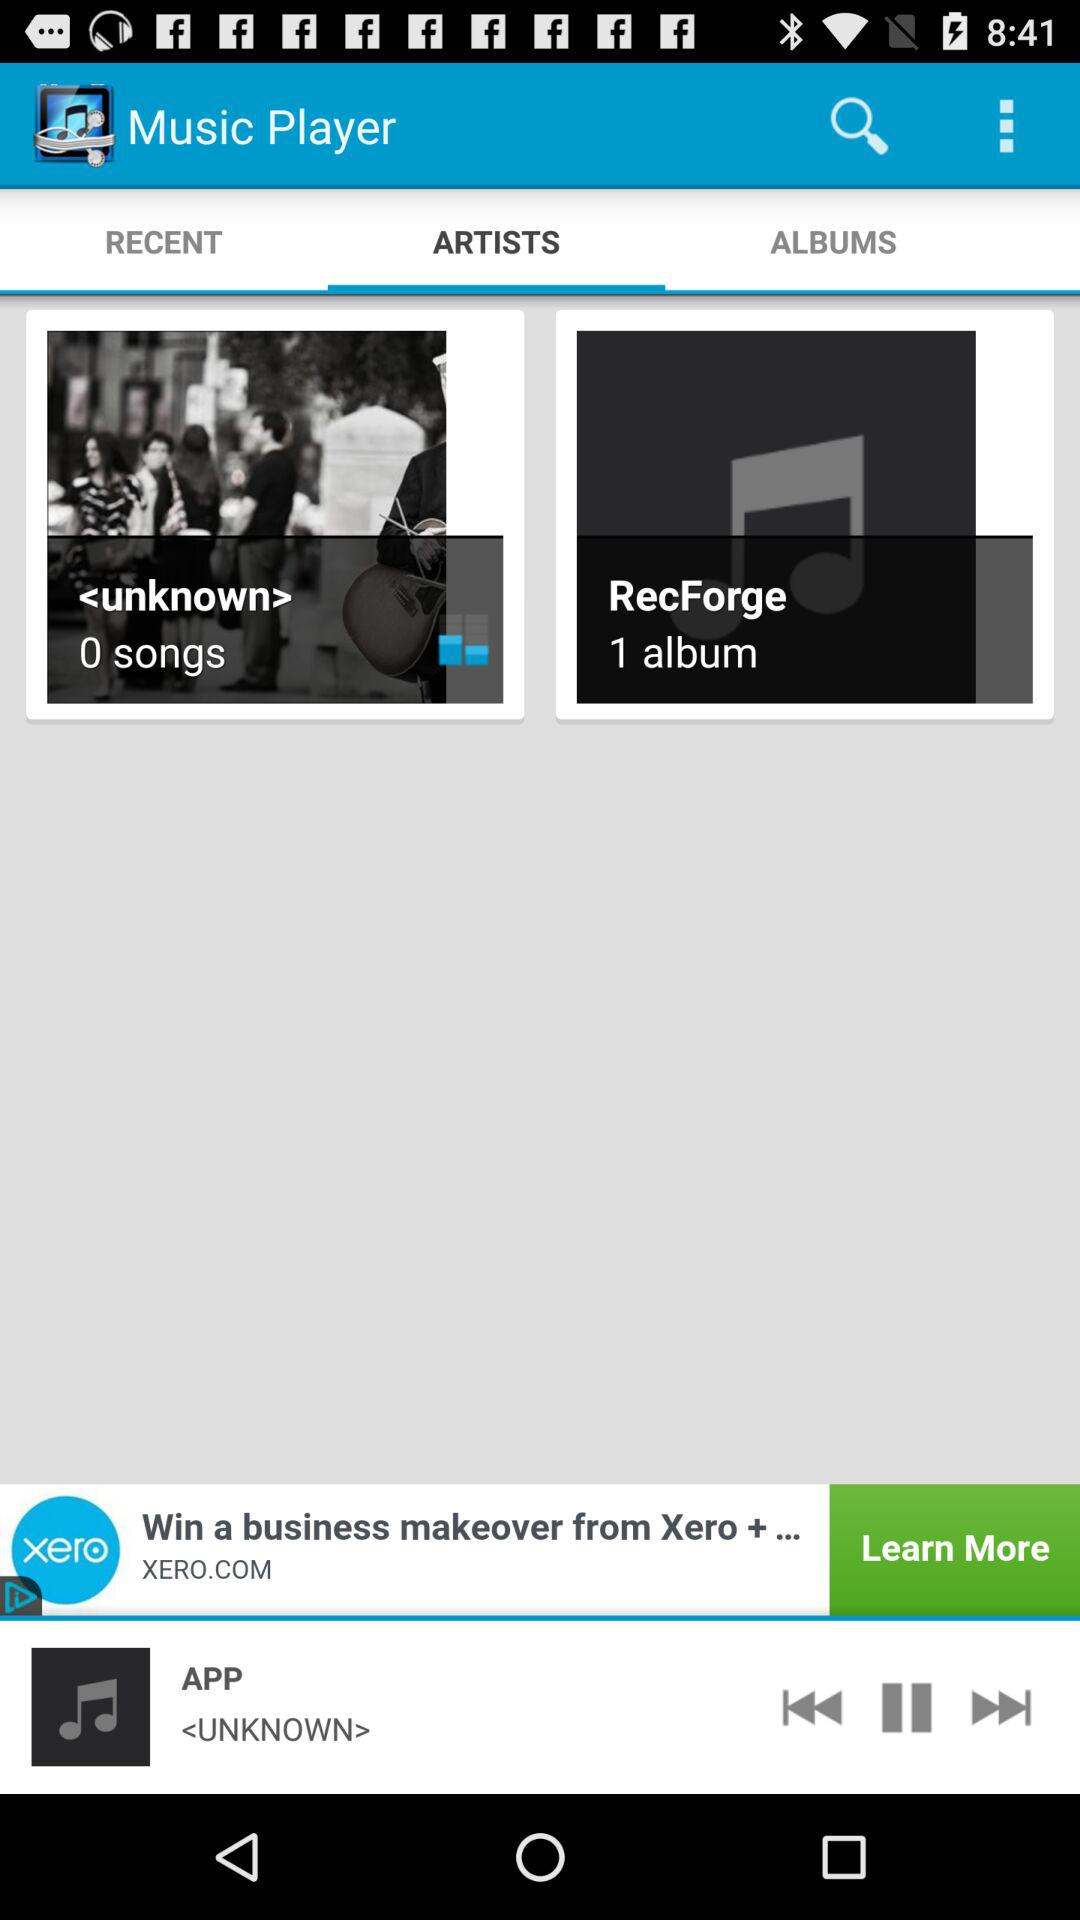Which tab is selected? The selected tab is "ARTISTS". 